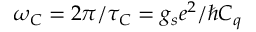Convert formula to latex. <formula><loc_0><loc_0><loc_500><loc_500>\omega _ { C } = 2 \pi / \tau _ { C } = g _ { s } e ^ { 2 } / \hbar { C } _ { q }</formula> 